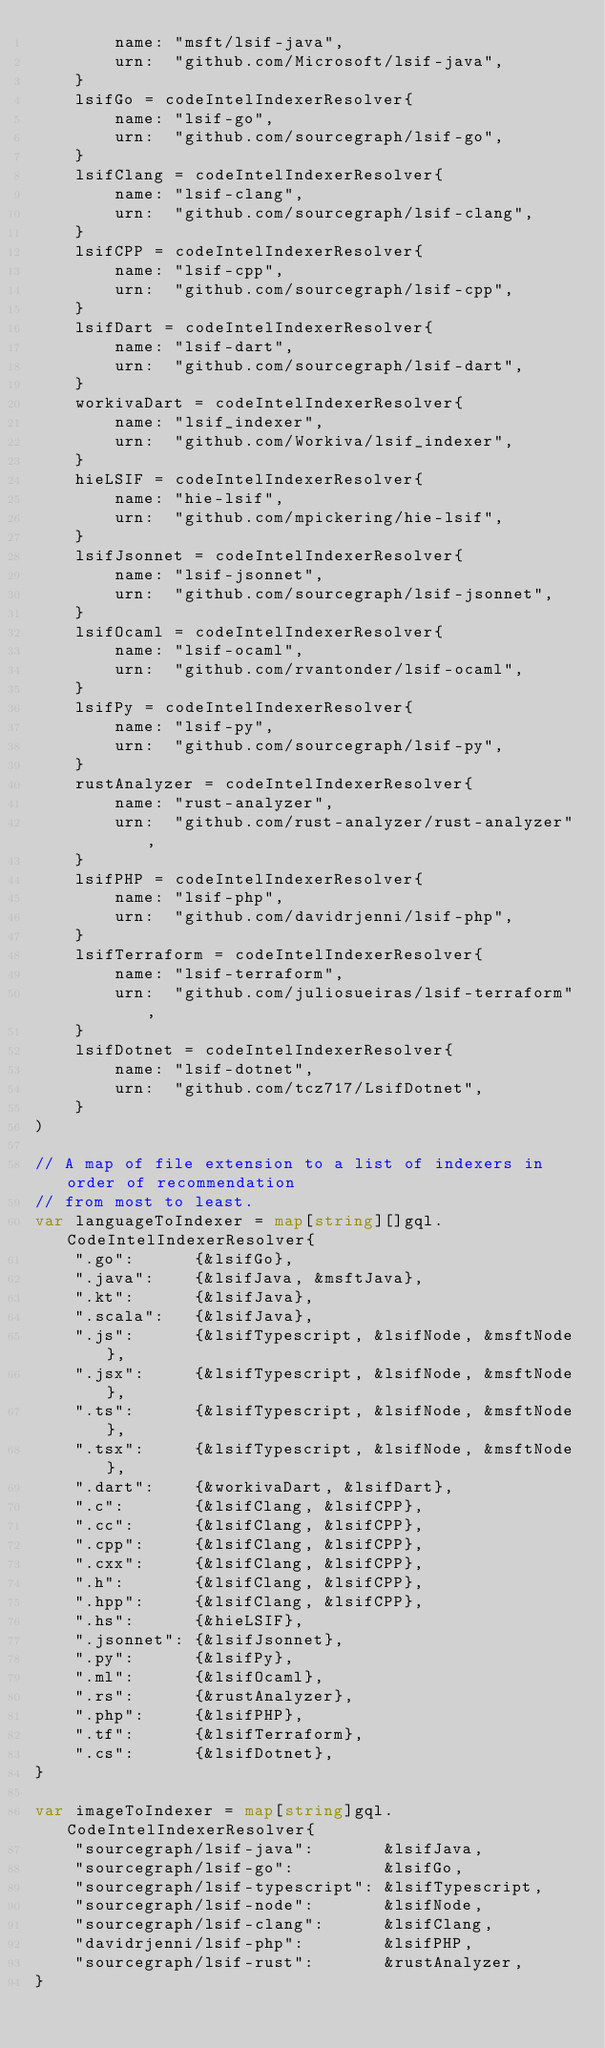Convert code to text. <code><loc_0><loc_0><loc_500><loc_500><_Go_>		name: "msft/lsif-java",
		urn:  "github.com/Microsoft/lsif-java",
	}
	lsifGo = codeIntelIndexerResolver{
		name: "lsif-go",
		urn:  "github.com/sourcegraph/lsif-go",
	}
	lsifClang = codeIntelIndexerResolver{
		name: "lsif-clang",
		urn:  "github.com/sourcegraph/lsif-clang",
	}
	lsifCPP = codeIntelIndexerResolver{
		name: "lsif-cpp",
		urn:  "github.com/sourcegraph/lsif-cpp",
	}
	lsifDart = codeIntelIndexerResolver{
		name: "lsif-dart",
		urn:  "github.com/sourcegraph/lsif-dart",
	}
	workivaDart = codeIntelIndexerResolver{
		name: "lsif_indexer",
		urn:  "github.com/Workiva/lsif_indexer",
	}
	hieLSIF = codeIntelIndexerResolver{
		name: "hie-lsif",
		urn:  "github.com/mpickering/hie-lsif",
	}
	lsifJsonnet = codeIntelIndexerResolver{
		name: "lsif-jsonnet",
		urn:  "github.com/sourcegraph/lsif-jsonnet",
	}
	lsifOcaml = codeIntelIndexerResolver{
		name: "lsif-ocaml",
		urn:  "github.com/rvantonder/lsif-ocaml",
	}
	lsifPy = codeIntelIndexerResolver{
		name: "lsif-py",
		urn:  "github.com/sourcegraph/lsif-py",
	}
	rustAnalyzer = codeIntelIndexerResolver{
		name: "rust-analyzer",
		urn:  "github.com/rust-analyzer/rust-analyzer",
	}
	lsifPHP = codeIntelIndexerResolver{
		name: "lsif-php",
		urn:  "github.com/davidrjenni/lsif-php",
	}
	lsifTerraform = codeIntelIndexerResolver{
		name: "lsif-terraform",
		urn:  "github.com/juliosueiras/lsif-terraform",
	}
	lsifDotnet = codeIntelIndexerResolver{
		name: "lsif-dotnet",
		urn:  "github.com/tcz717/LsifDotnet",
	}
)

// A map of file extension to a list of indexers in order of recommendation
// from most to least.
var languageToIndexer = map[string][]gql.CodeIntelIndexerResolver{
	".go":      {&lsifGo},
	".java":    {&lsifJava, &msftJava},
	".kt":      {&lsifJava},
	".scala":   {&lsifJava},
	".js":      {&lsifTypescript, &lsifNode, &msftNode},
	".jsx":     {&lsifTypescript, &lsifNode, &msftNode},
	".ts":      {&lsifTypescript, &lsifNode, &msftNode},
	".tsx":     {&lsifTypescript, &lsifNode, &msftNode},
	".dart":    {&workivaDart, &lsifDart},
	".c":       {&lsifClang, &lsifCPP},
	".cc":      {&lsifClang, &lsifCPP},
	".cpp":     {&lsifClang, &lsifCPP},
	".cxx":     {&lsifClang, &lsifCPP},
	".h":       {&lsifClang, &lsifCPP},
	".hpp":     {&lsifClang, &lsifCPP},
	".hs":      {&hieLSIF},
	".jsonnet": {&lsifJsonnet},
	".py":      {&lsifPy},
	".ml":      {&lsifOcaml},
	".rs":      {&rustAnalyzer},
	".php":     {&lsifPHP},
	".tf":      {&lsifTerraform},
	".cs":      {&lsifDotnet},
}

var imageToIndexer = map[string]gql.CodeIntelIndexerResolver{
	"sourcegraph/lsif-java":       &lsifJava,
	"sourcegraph/lsif-go":         &lsifGo,
	"sourcegraph/lsif-typescript": &lsifTypescript,
	"sourcegraph/lsif-node":       &lsifNode,
	"sourcegraph/lsif-clang":      &lsifClang,
	"davidrjenni/lsif-php":        &lsifPHP,
	"sourcegraph/lsif-rust":       &rustAnalyzer,
}
</code> 